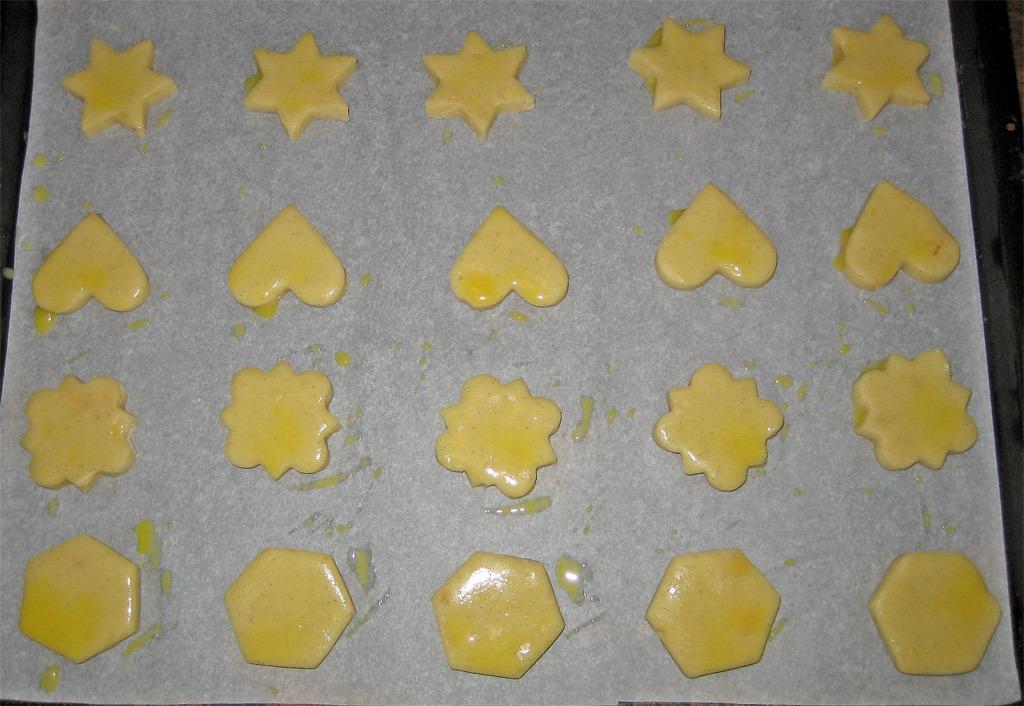Could you give a brief overview of what you see in this image? In this picture we can see some food items in different shapes on the paper and the paper is on the black object. 